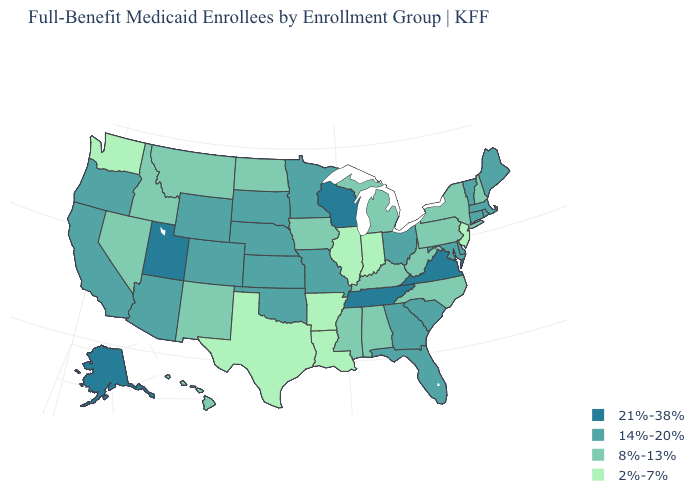Which states have the highest value in the USA?
Short answer required. Alaska, Tennessee, Utah, Virginia, Wisconsin. Does Pennsylvania have a higher value than Arkansas?
Short answer required. Yes. Does Alaska have the highest value in the USA?
Quick response, please. Yes. Name the states that have a value in the range 14%-20%?
Quick response, please. Arizona, California, Colorado, Connecticut, Delaware, Florida, Georgia, Kansas, Maine, Maryland, Massachusetts, Minnesota, Missouri, Nebraska, Ohio, Oklahoma, Oregon, Rhode Island, South Carolina, South Dakota, Vermont, Wyoming. Name the states that have a value in the range 14%-20%?
Be succinct. Arizona, California, Colorado, Connecticut, Delaware, Florida, Georgia, Kansas, Maine, Maryland, Massachusetts, Minnesota, Missouri, Nebraska, Ohio, Oklahoma, Oregon, Rhode Island, South Carolina, South Dakota, Vermont, Wyoming. What is the value of Massachusetts?
Short answer required. 14%-20%. Does South Dakota have a lower value than Kentucky?
Give a very brief answer. No. What is the value of North Carolina?
Concise answer only. 8%-13%. Name the states that have a value in the range 21%-38%?
Be succinct. Alaska, Tennessee, Utah, Virginia, Wisconsin. Name the states that have a value in the range 14%-20%?
Short answer required. Arizona, California, Colorado, Connecticut, Delaware, Florida, Georgia, Kansas, Maine, Maryland, Massachusetts, Minnesota, Missouri, Nebraska, Ohio, Oklahoma, Oregon, Rhode Island, South Carolina, South Dakota, Vermont, Wyoming. Name the states that have a value in the range 21%-38%?
Write a very short answer. Alaska, Tennessee, Utah, Virginia, Wisconsin. What is the value of Texas?
Keep it brief. 2%-7%. Does Alaska have the highest value in the West?
Answer briefly. Yes. What is the highest value in the USA?
Write a very short answer. 21%-38%. What is the lowest value in the South?
Short answer required. 2%-7%. 